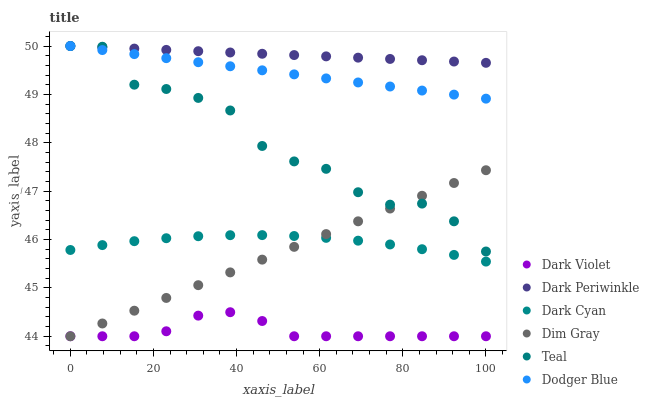Does Dark Violet have the minimum area under the curve?
Answer yes or no. Yes. Does Dark Periwinkle have the maximum area under the curve?
Answer yes or no. Yes. Does Dodger Blue have the minimum area under the curve?
Answer yes or no. No. Does Dodger Blue have the maximum area under the curve?
Answer yes or no. No. Is Dim Gray the smoothest?
Answer yes or no. Yes. Is Teal the roughest?
Answer yes or no. Yes. Is Dark Violet the smoothest?
Answer yes or no. No. Is Dark Violet the roughest?
Answer yes or no. No. Does Dim Gray have the lowest value?
Answer yes or no. Yes. Does Dodger Blue have the lowest value?
Answer yes or no. No. Does Dark Periwinkle have the highest value?
Answer yes or no. Yes. Does Dark Violet have the highest value?
Answer yes or no. No. Is Dark Violet less than Teal?
Answer yes or no. Yes. Is Teal greater than Dark Cyan?
Answer yes or no. Yes. Does Dim Gray intersect Dark Violet?
Answer yes or no. Yes. Is Dim Gray less than Dark Violet?
Answer yes or no. No. Is Dim Gray greater than Dark Violet?
Answer yes or no. No. Does Dark Violet intersect Teal?
Answer yes or no. No. 